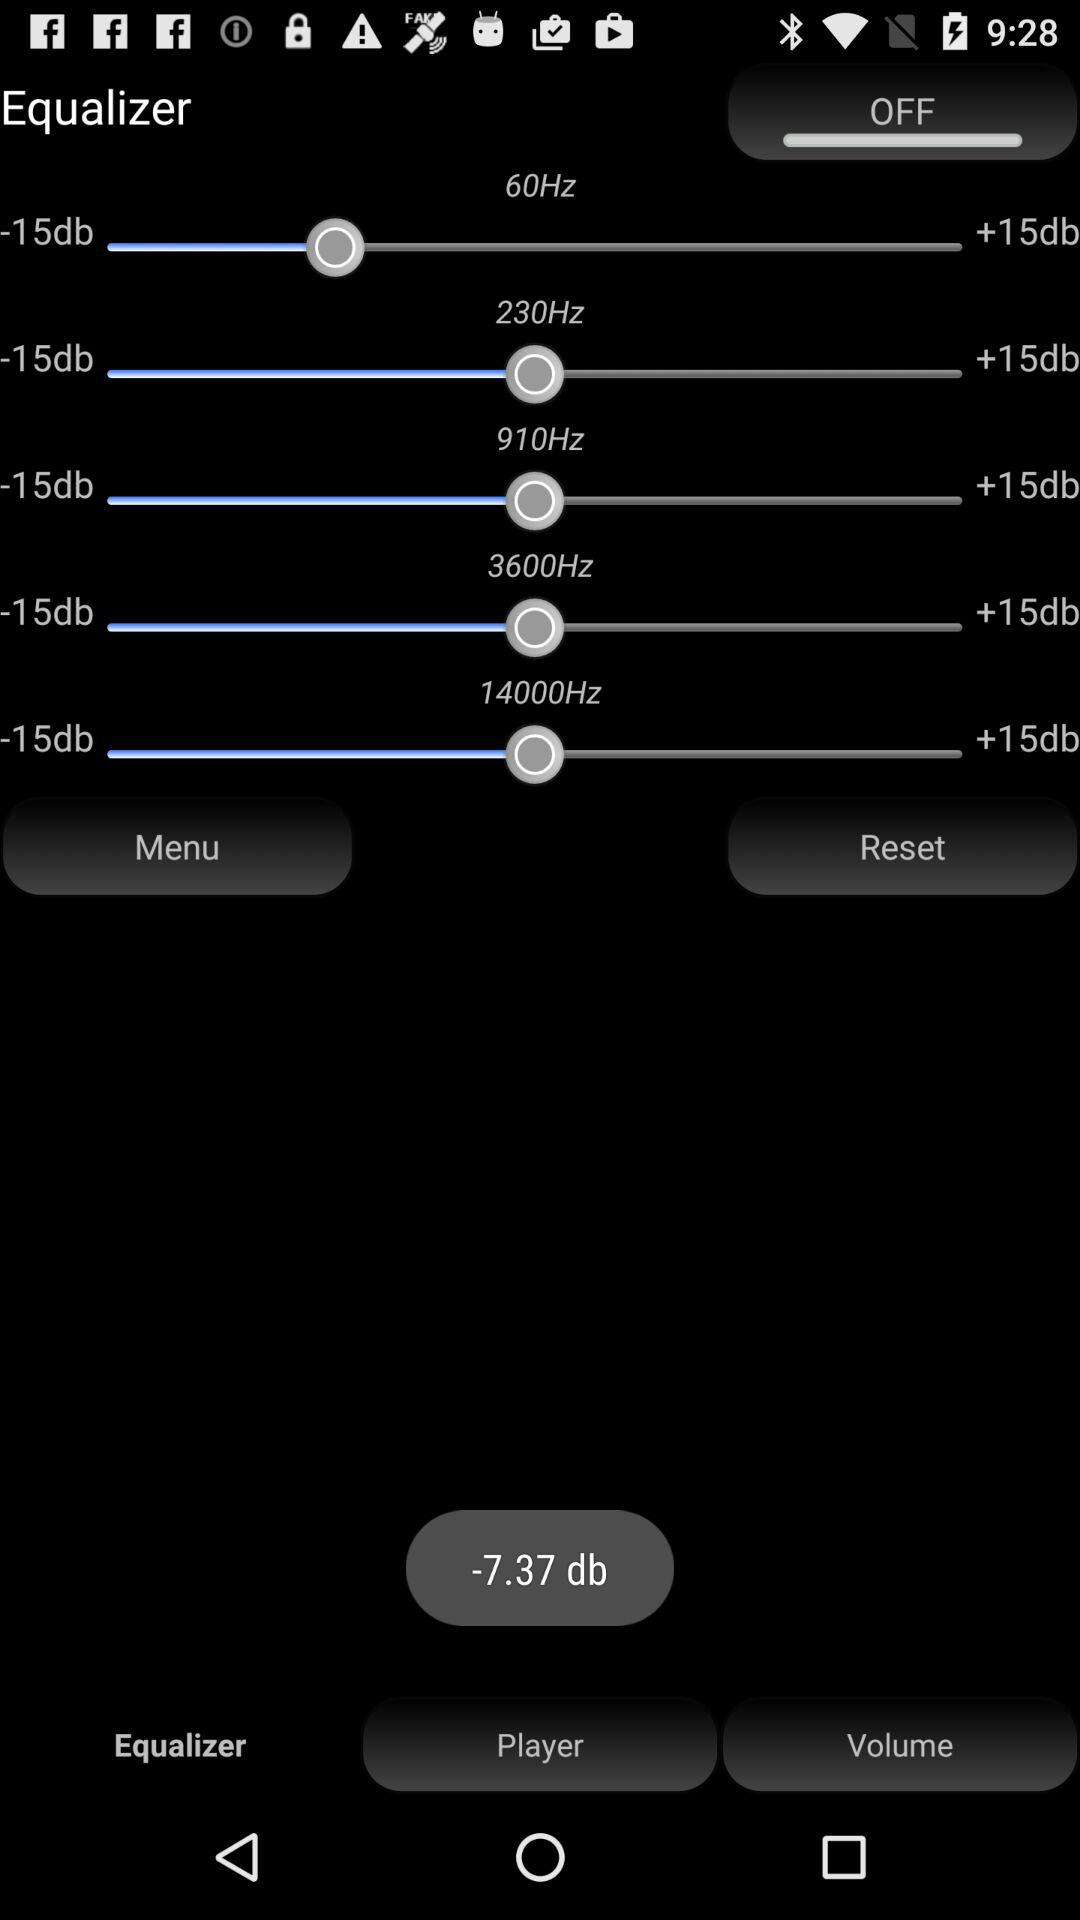What is the current status of the equalizer? The current status of the equalizer is off. 